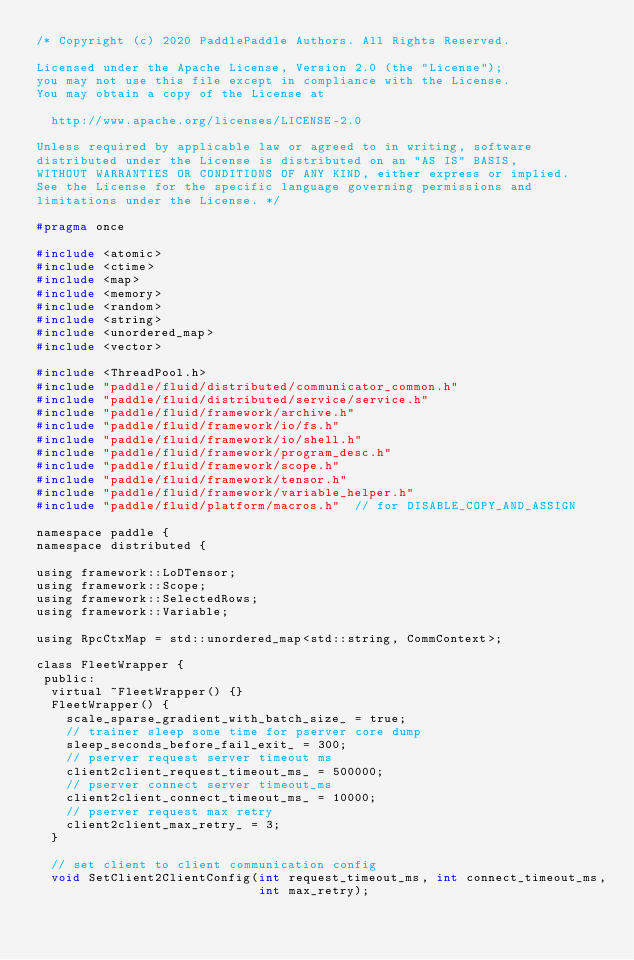Convert code to text. <code><loc_0><loc_0><loc_500><loc_500><_C_>/* Copyright (c) 2020 PaddlePaddle Authors. All Rights Reserved.

Licensed under the Apache License, Version 2.0 (the "License");
you may not use this file except in compliance with the License.
You may obtain a copy of the License at

  http://www.apache.org/licenses/LICENSE-2.0

Unless required by applicable law or agreed to in writing, software
distributed under the License is distributed on an "AS IS" BASIS,
WITHOUT WARRANTIES OR CONDITIONS OF ANY KIND, either express or implied.
See the License for the specific language governing permissions and
limitations under the License. */

#pragma once

#include <atomic>
#include <ctime>
#include <map>
#include <memory>
#include <random>
#include <string>
#include <unordered_map>
#include <vector>

#include <ThreadPool.h>
#include "paddle/fluid/distributed/communicator_common.h"
#include "paddle/fluid/distributed/service/service.h"
#include "paddle/fluid/framework/archive.h"
#include "paddle/fluid/framework/io/fs.h"
#include "paddle/fluid/framework/io/shell.h"
#include "paddle/fluid/framework/program_desc.h"
#include "paddle/fluid/framework/scope.h"
#include "paddle/fluid/framework/tensor.h"
#include "paddle/fluid/framework/variable_helper.h"
#include "paddle/fluid/platform/macros.h"  // for DISABLE_COPY_AND_ASSIGN

namespace paddle {
namespace distributed {

using framework::LoDTensor;
using framework::Scope;
using framework::SelectedRows;
using framework::Variable;

using RpcCtxMap = std::unordered_map<std::string, CommContext>;

class FleetWrapper {
 public:
  virtual ~FleetWrapper() {}
  FleetWrapper() {
    scale_sparse_gradient_with_batch_size_ = true;
    // trainer sleep some time for pserver core dump
    sleep_seconds_before_fail_exit_ = 300;
    // pserver request server timeout ms
    client2client_request_timeout_ms_ = 500000;
    // pserver connect server timeout_ms
    client2client_connect_timeout_ms_ = 10000;
    // pserver request max retry
    client2client_max_retry_ = 3;
  }

  // set client to client communication config
  void SetClient2ClientConfig(int request_timeout_ms, int connect_timeout_ms,
                              int max_retry);
</code> 